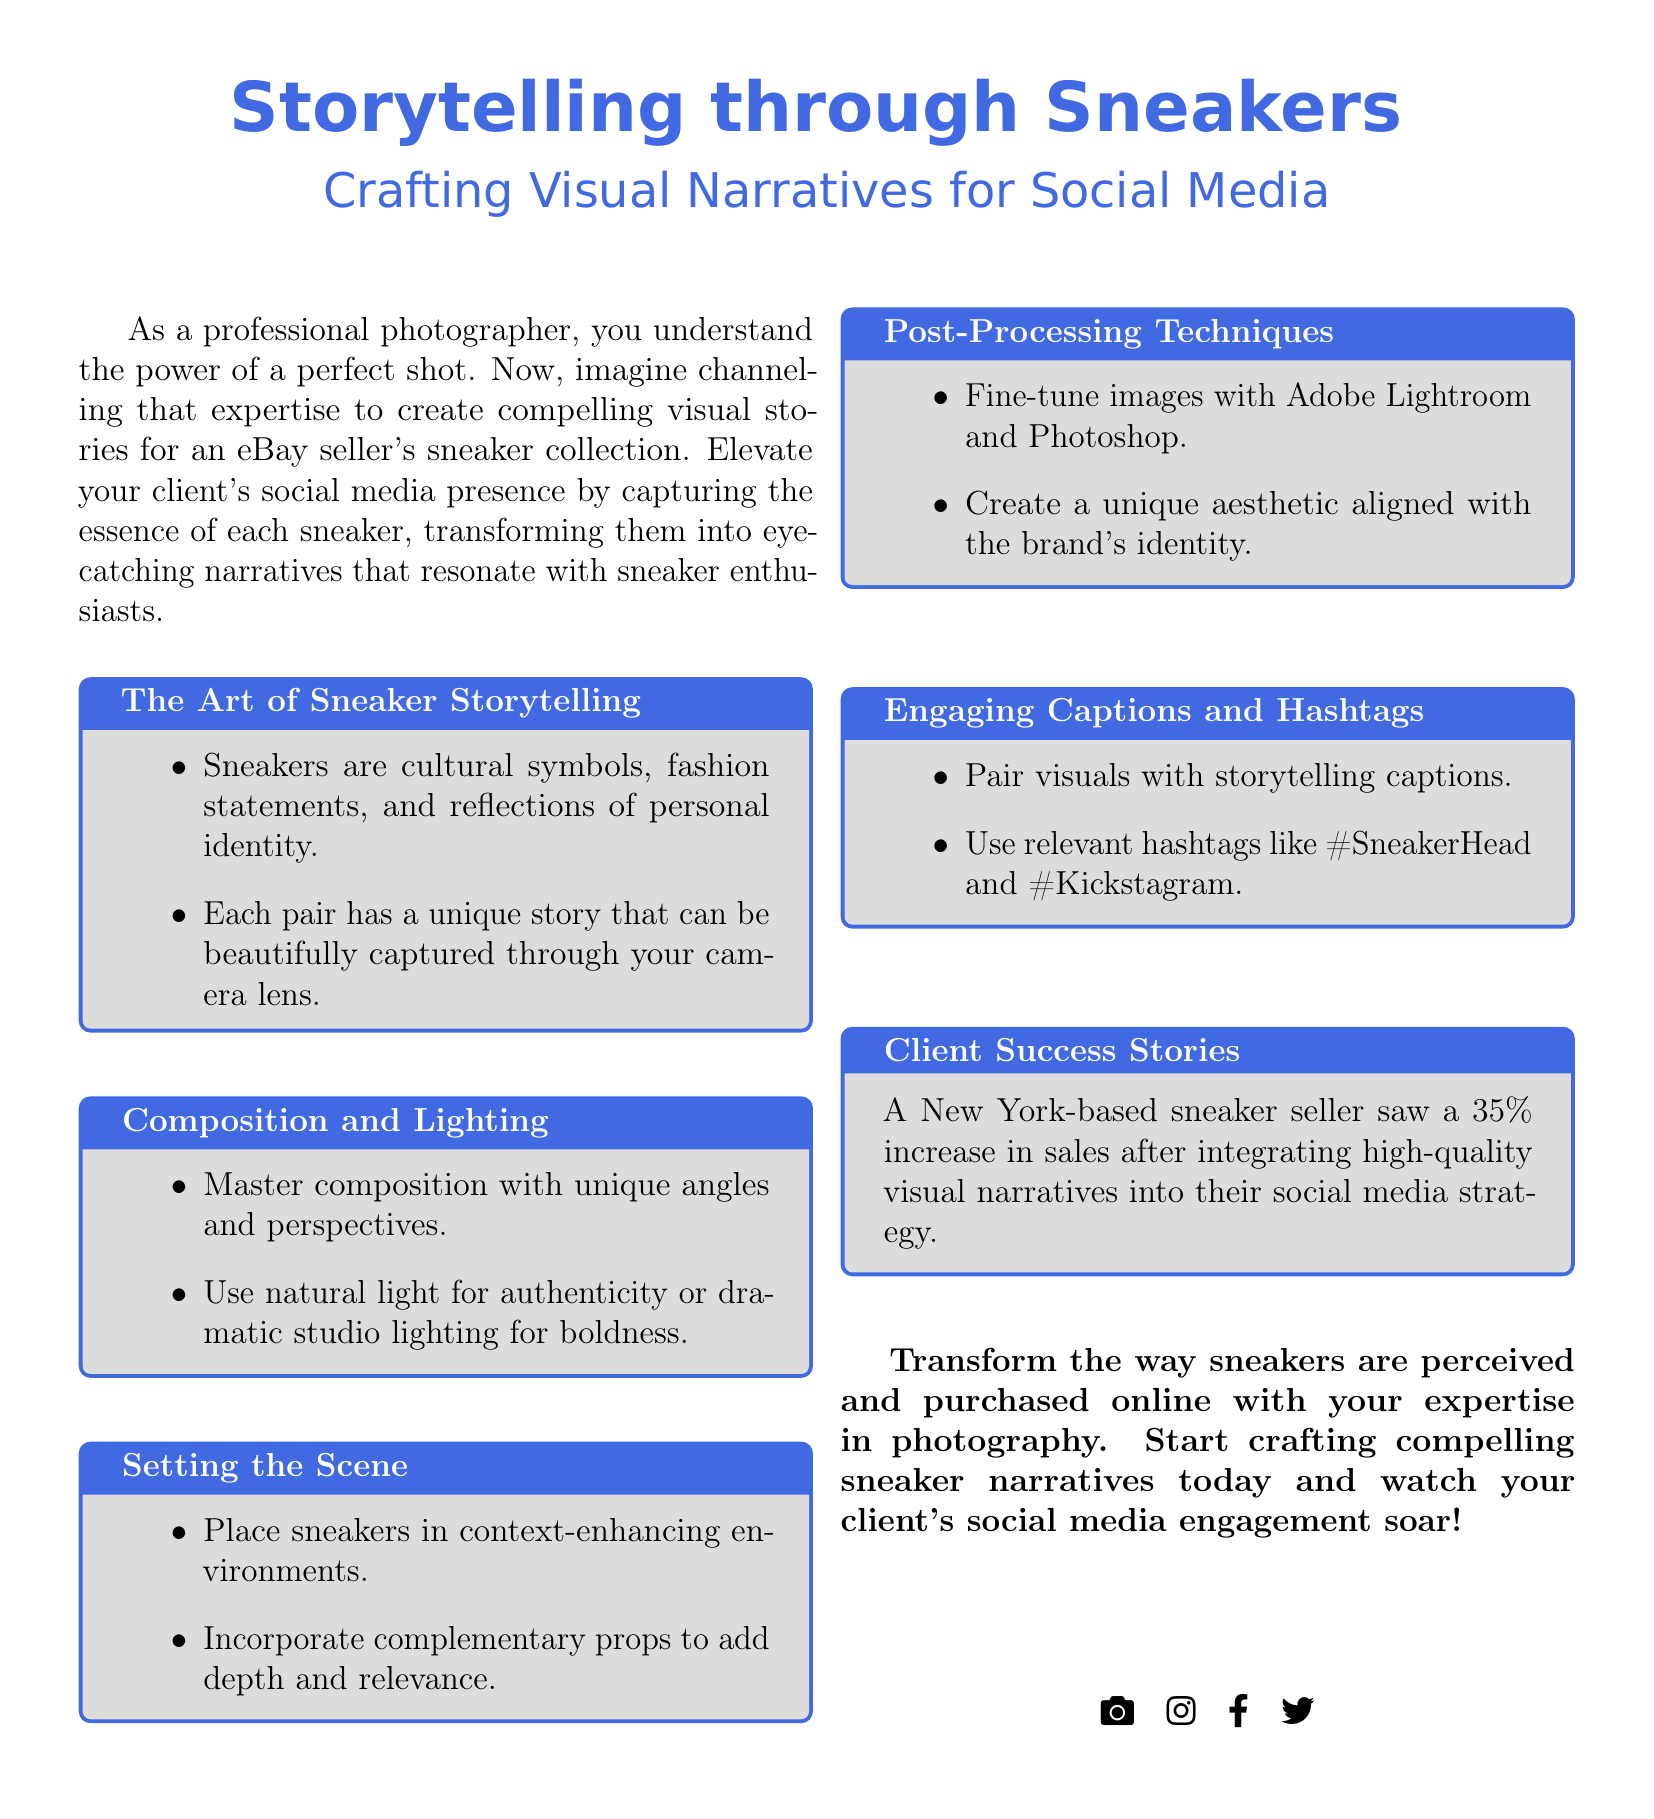What is the title of the advertisement? The title of the advertisement is clearly stated at the top of the document.
Answer: Storytelling through Sneakers What color is featured in the advertisements for backgrounds? The color used for backgrounds is specified as sneakergray in the document.
Answer: sneakergray What is the percentage increase in sales mentioned? The percentage increase in sales from client success stories is noted in the document.
Answer: 35% What can be fine-tuned with Adobe Lightroom and Photoshop? The document lists post-processing techniques that involve specific software for enhancing images.
Answer: Images What should captions be paired with? The document emphasizes the importance of pairing visuals with another element to enhance storytelling.
Answer: Storytelling captions How should sneakers be placed in photographs? The document suggests a specific way to present sneakers, enhancing the overall aesthetic of the shot.
Answer: In context-enhancing environments What is the purpose of the advertisement? The main goal of the advertisement focuses on transforming perceptions and engagements related to sneaker photography.
Answer: Crafting compelling sneaker narratives What are some relevant hashtags mentioned? The document lists specific hashtags that are recommended for social media promotion related to sneakers.
Answer: #SneakerHead, #Kickstagram What is emphasized about the power of a shot? The document captures the essence of photography's impact and establishes its significance in storytelling.
Answer: The power of a perfect shot 